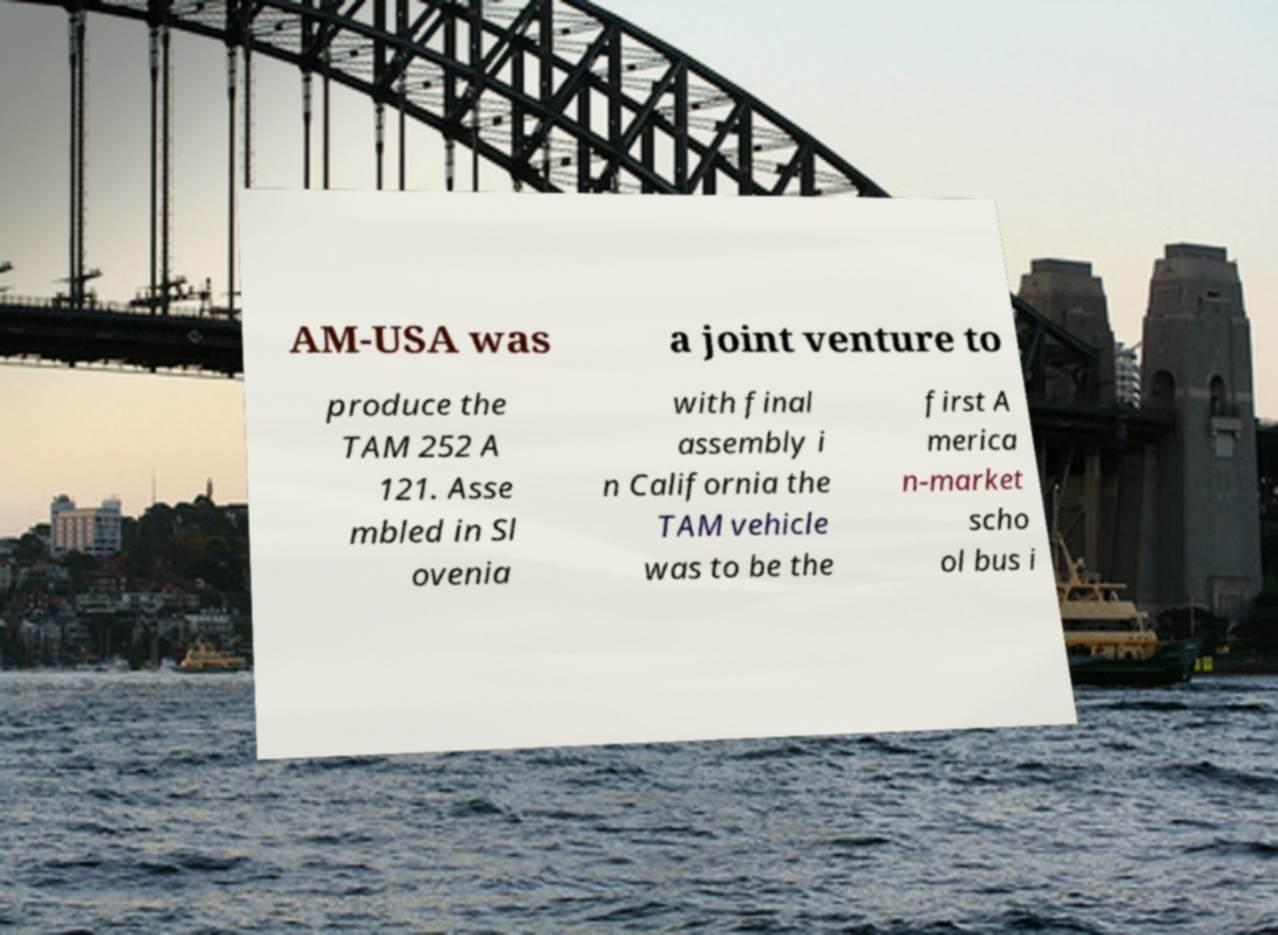There's text embedded in this image that I need extracted. Can you transcribe it verbatim? AM-USA was a joint venture to produce the TAM 252 A 121. Asse mbled in Sl ovenia with final assembly i n California the TAM vehicle was to be the first A merica n-market scho ol bus i 